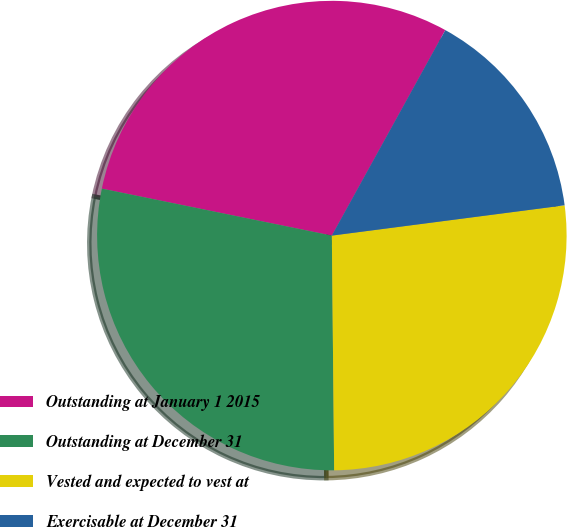Convert chart to OTSL. <chart><loc_0><loc_0><loc_500><loc_500><pie_chart><fcel>Outstanding at January 1 2015<fcel>Outstanding at December 31<fcel>Vested and expected to vest at<fcel>Exercisable at December 31<nl><fcel>29.82%<fcel>28.36%<fcel>26.9%<fcel>14.91%<nl></chart> 